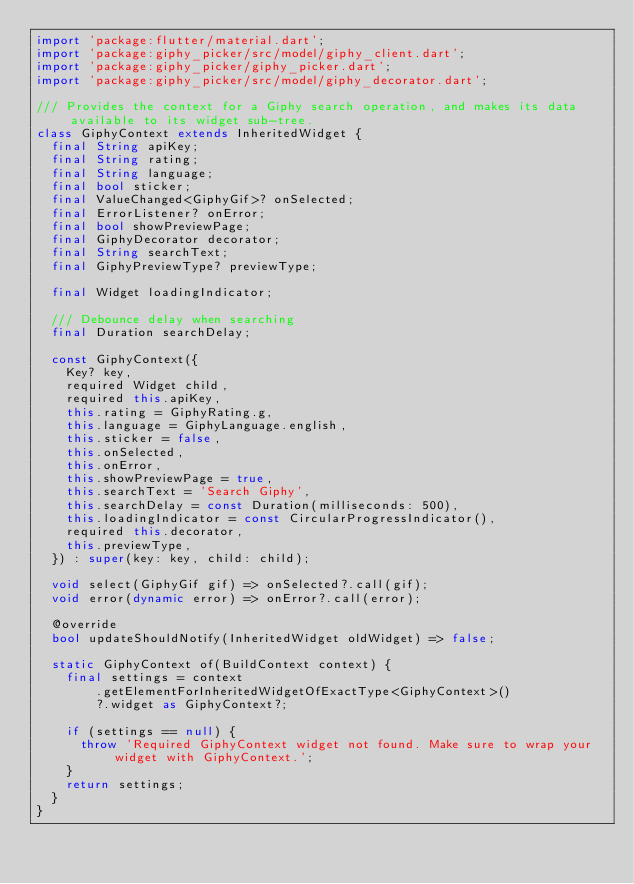<code> <loc_0><loc_0><loc_500><loc_500><_Dart_>import 'package:flutter/material.dart';
import 'package:giphy_picker/src/model/giphy_client.dart';
import 'package:giphy_picker/giphy_picker.dart';
import 'package:giphy_picker/src/model/giphy_decorator.dart';

/// Provides the context for a Giphy search operation, and makes its data available to its widget sub-tree.
class GiphyContext extends InheritedWidget {
  final String apiKey;
  final String rating;
  final String language;
  final bool sticker;
  final ValueChanged<GiphyGif>? onSelected;
  final ErrorListener? onError;
  final bool showPreviewPage;
  final GiphyDecorator decorator;
  final String searchText;
  final GiphyPreviewType? previewType;

  final Widget loadingIndicator;

  /// Debounce delay when searching
  final Duration searchDelay;

  const GiphyContext({
    Key? key,
    required Widget child,
    required this.apiKey,
    this.rating = GiphyRating.g,
    this.language = GiphyLanguage.english,
    this.sticker = false,
    this.onSelected,
    this.onError,
    this.showPreviewPage = true,
    this.searchText = 'Search Giphy',
    this.searchDelay = const Duration(milliseconds: 500),
    this.loadingIndicator = const CircularProgressIndicator(),
    required this.decorator,
    this.previewType,
  }) : super(key: key, child: child);

  void select(GiphyGif gif) => onSelected?.call(gif);
  void error(dynamic error) => onError?.call(error);

  @override
  bool updateShouldNotify(InheritedWidget oldWidget) => false;

  static GiphyContext of(BuildContext context) {
    final settings = context
        .getElementForInheritedWidgetOfExactType<GiphyContext>()
        ?.widget as GiphyContext?;

    if (settings == null) {
      throw 'Required GiphyContext widget not found. Make sure to wrap your widget with GiphyContext.';
    }
    return settings;
  }
}
</code> 